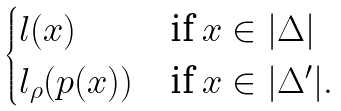Convert formula to latex. <formula><loc_0><loc_0><loc_500><loc_500>\begin{cases} l ( x ) & \text {if $x\in | \Delta |$} \\ l _ { \rho } ( p ( x ) ) & \text {if $x\in | \Delta ^{\prime} | .$} \end{cases}</formula> 